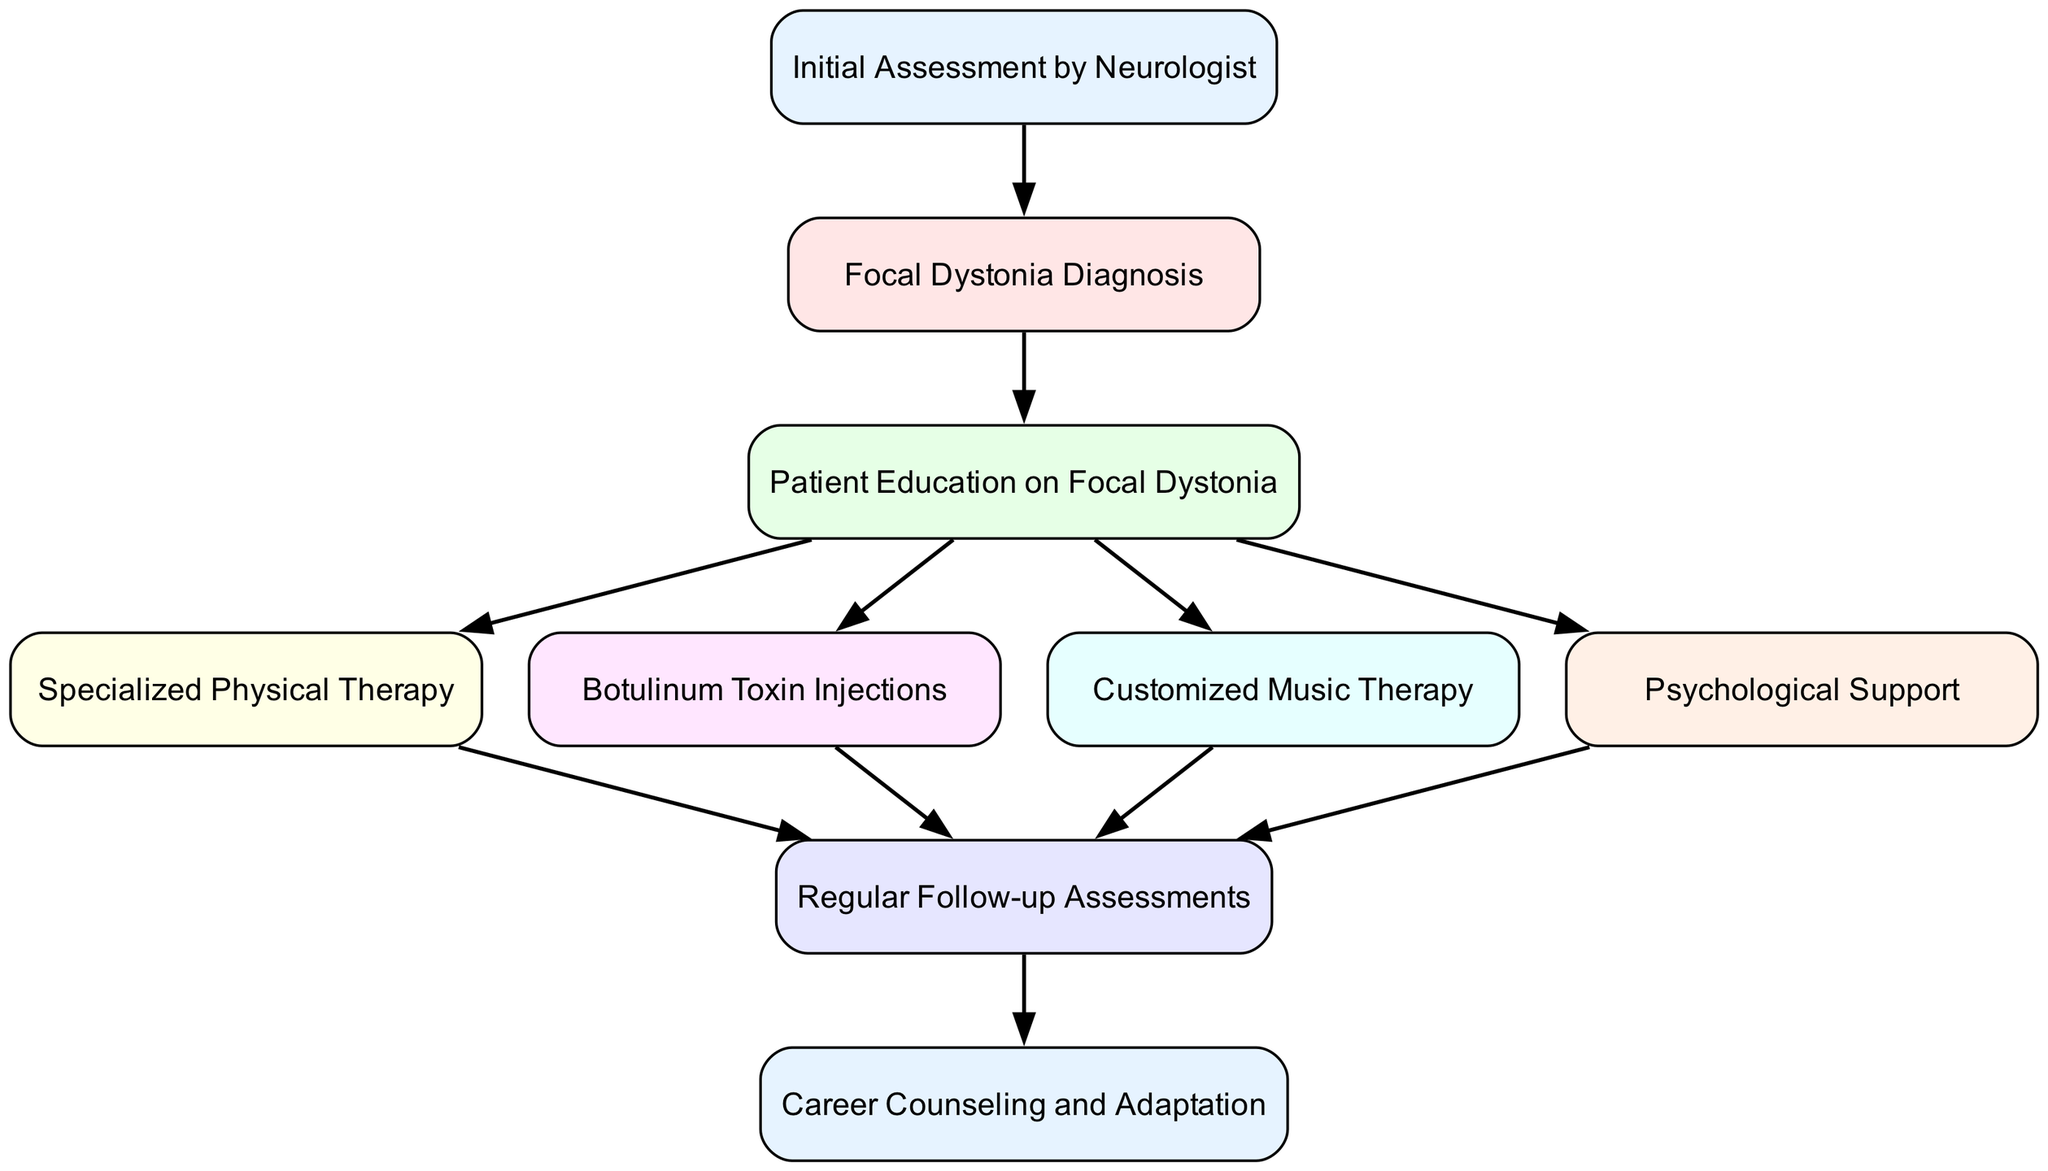What is the first step in the rehabilitation pathway? The first step is the "Initial Assessment by Neurologist," which is the starting point of the clinical pathway where the patient is evaluated.
Answer: Initial Assessment by Neurologist How many nodes are included in the diagram? By counting all the distinct steps (nodes) listed in the data, there are a total of 9 nodes present in the diagram.
Answer: 9 What type of therapy follows education? According to the diagram, after "Patient Education on Focal Dystonia," the next step is "Specialized Physical Therapy."
Answer: Specialized Physical Therapy Which therapies are linked directly after education? From "Patient Education on Focal Dystonia," the diagram shows direct connections to "Specialized Physical Therapy," "Botulinum Toxin Injections," "Customized Music Therapy," and "Psychological Support."
Answer: Specialized Physical Therapy, Botulinum Toxin Injections, Customized Music Therapy, Psychological Support What does the follow-up lead to? The "Regular Follow-up Assessments" leads to "Career Counseling and Adaptation," indicating that follow-ups may influence career decisions.
Answer: Career Counseling and Adaptation Which intervention has the most connections? The node "Patient Education on Focal Dystonia" connects to four different therapies, making it the most connected node in the diagram.
Answer: Patient Education on Focal Dystonia How many edges are present in the diagram? By counting the relationships (edges) defined in the data, we see that there are a total of 10 edges connecting the nodes in the diagram.
Answer: 10 What role does psychological support play in the pathway? "Psychological Support" is a step that occurs after "Patient Education on Focal Dystonia" and is connected to "Regular Follow-up Assessments," indicating its importance in the overall rehabilitation.
Answer: Important role after education What is the relationship between botox and follow-up? The diagram shows a direct connection where "Botulinum Toxin Injections" leads to "Regular Follow-up Assessments," suggesting that patients undergoing this treatment will have follow-up evaluations.
Answer: Direct connection 